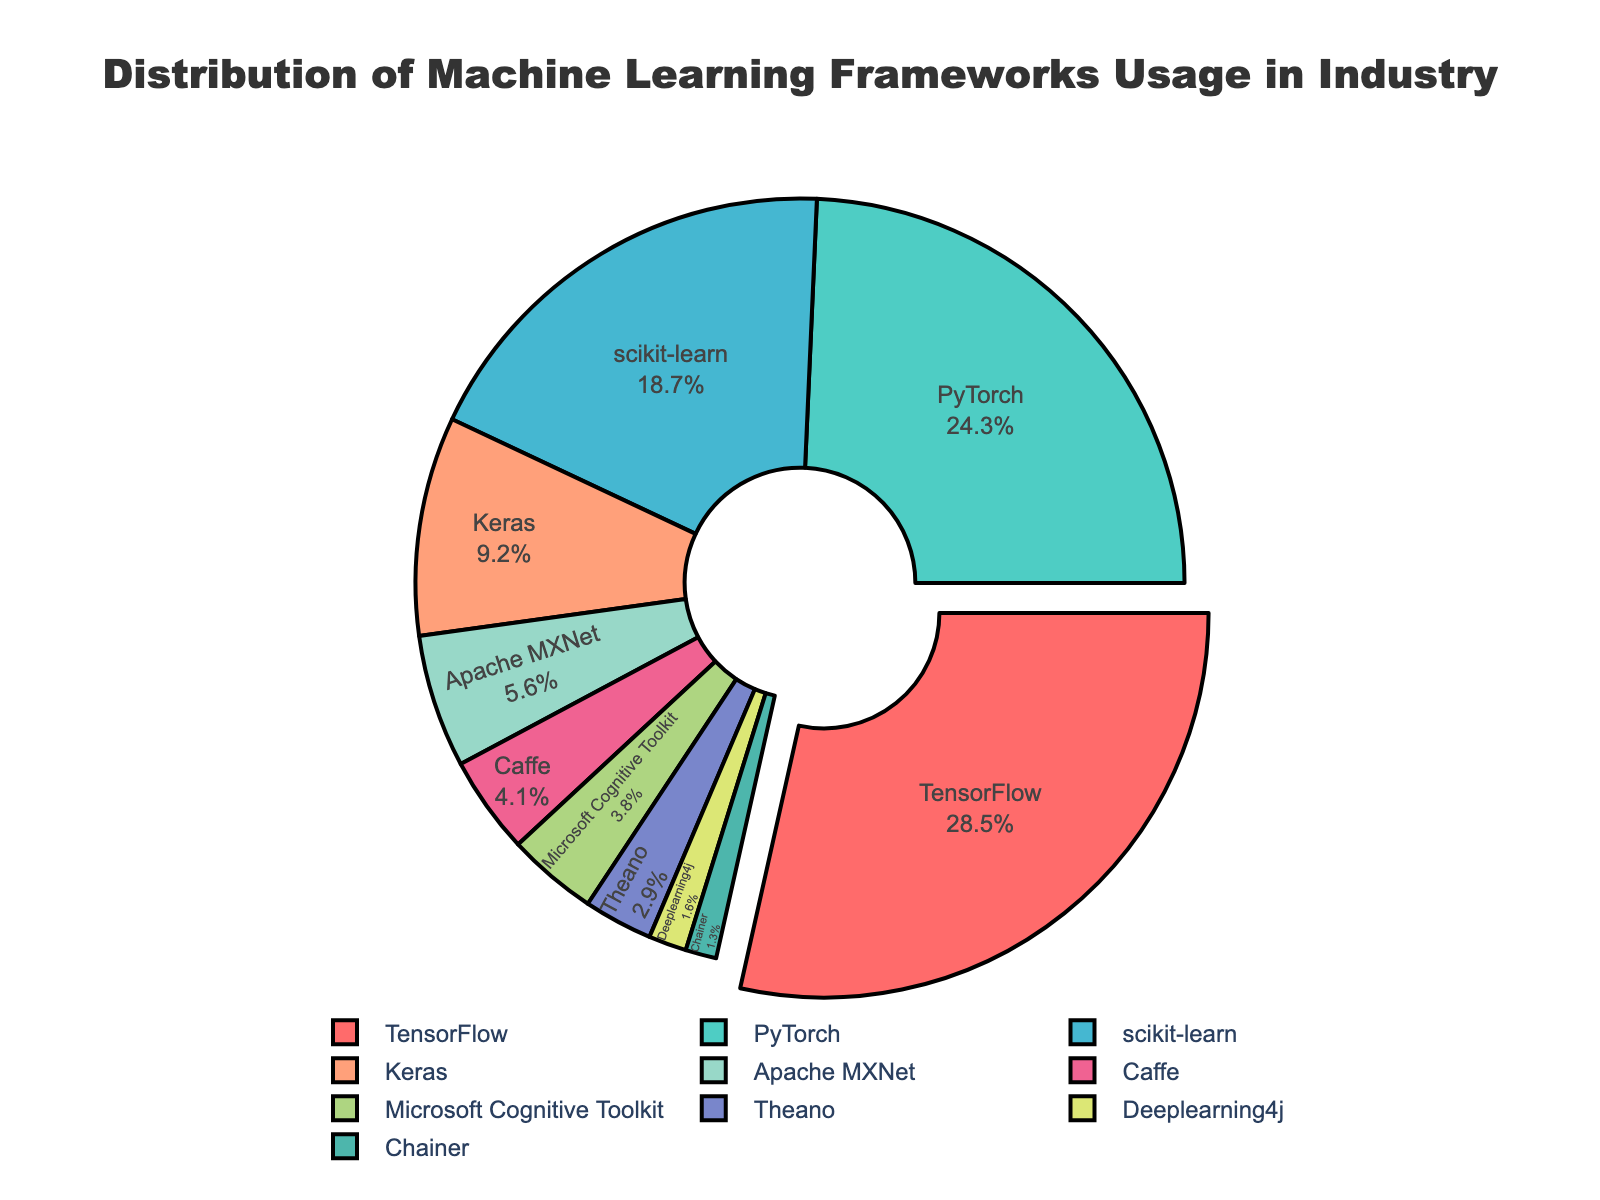What percentage of the pie chart does TensorFlow cover? TensorFlow covers 28.5% of the pie chart as indicated directly on the chart itself.
Answer: 28.5% Which two frameworks have the closest usage percentages? PyTorch (24.3%) and TensorFlow (28.5%) are close, but scikit-learn (18.7%) and Keras (9.2%) are closer. Subtracting the smaller percentage from the larger gives 18.7 - 9.2 = 9.5.
Answer: scikit-learn and Keras What is the combined percentage of frameworks that each have less than 5% usage? Sum the percentages of Apache MXNet (5.6%), Caffe (4.1%), Microsoft Cognitive Toolkit (3.8%), Theano (2.9%), Deeplearning4j (1.6%), and Chainer (1.3%): 5.6 + 4.1 + 3.8 + 2.9 + 1.6 + 1.3 = 19.3%
Answer: 19.3% Which framework has its slice slightly pulled out from the chart, and why? TensorFlow's slice is slightly pulled out from the chart to highlight that it has the highest percentage.
Answer: TensorFlow Is PyTorch usage greater than or equal to the combined usage of Caffe and Theano? PyTorch usage is 24.3%. Combined usage of Caffe (4.1%) and Theano (2.9%) is 4.1 + 2.9 = 7%. Since 24.3% > 7%, PyTorch usage is greater.
Answer: Yes Which color represents the framework with the third highest usage? Scikit-learn is the framework with the third highest usage (18.7%), which is represented by the pale blue color in the chart.
Answer: Pale blue What is the total percentage usage for TensorFlow, PyTorch, and scikit-learn combined? Sum the percentages: TensorFlow (28.5%) + PyTorch (24.3%) + scikit-learn (18.7%) = 28.5 + 24.3 + 18.7 = 71.5%
Answer: 71.5% How does the usage percentage of Caffe compare to that of Keras? Keras has a usage percentage of 9.2%, whereas Caffe has 4.1%. Since 4.1% is less than 9.2%, Caffe’s usage is lower than Keras's.
Answer: Lower What color is the smallest slice in the chart, and which framework does it represent? The smallest slice is represented by the light orange color, which corresponds to Chainer with 1.3% usage.
Answer: Light orange, Chainer What is the average percentage usage of the top three frameworks? The top three frameworks are TensorFlow (28.5%), PyTorch (24.3%), and scikit-learn (18.7%). The average is calculated by (28.5 + 24.3 + 18.7) / 3 = 24.5%.
Answer: 24.5% 